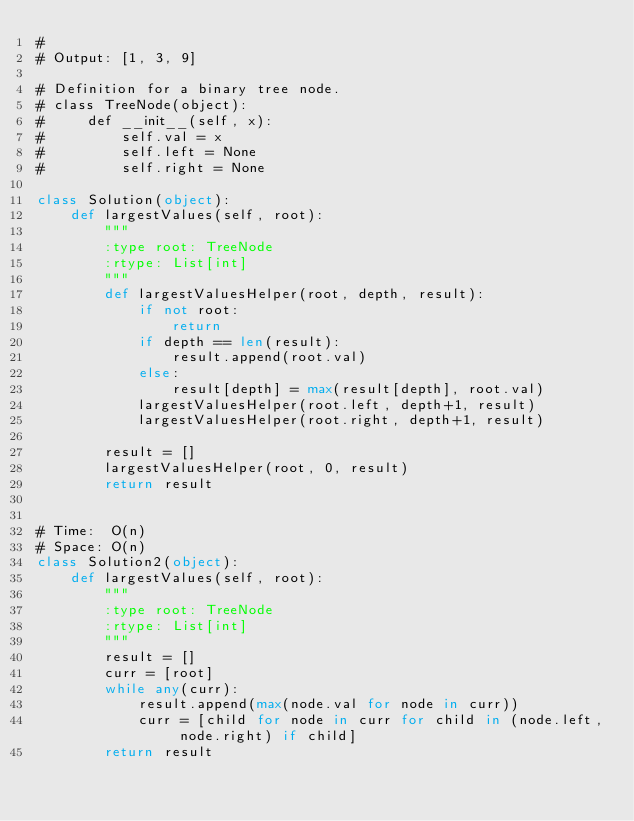Convert code to text. <code><loc_0><loc_0><loc_500><loc_500><_Python_>#
# Output: [1, 3, 9]

# Definition for a binary tree node.
# class TreeNode(object):
#     def __init__(self, x):
#         self.val = x
#         self.left = None
#         self.right = None

class Solution(object):
    def largestValues(self, root):
        """
        :type root: TreeNode
        :rtype: List[int]
        """
        def largestValuesHelper(root, depth, result):
            if not root:
                return
            if depth == len(result):
                result.append(root.val)
            else:
                result[depth] = max(result[depth], root.val)
            largestValuesHelper(root.left, depth+1, result)
            largestValuesHelper(root.right, depth+1, result)

        result = []
        largestValuesHelper(root, 0, result)
        return result


# Time:  O(n)
# Space: O(n)
class Solution2(object):
    def largestValues(self, root):
        """
        :type root: TreeNode
        :rtype: List[int]
        """
        result = []
        curr = [root]
        while any(curr):
            result.append(max(node.val for node in curr))
            curr = [child for node in curr for child in (node.left, node.right) if child]
        return result

</code> 